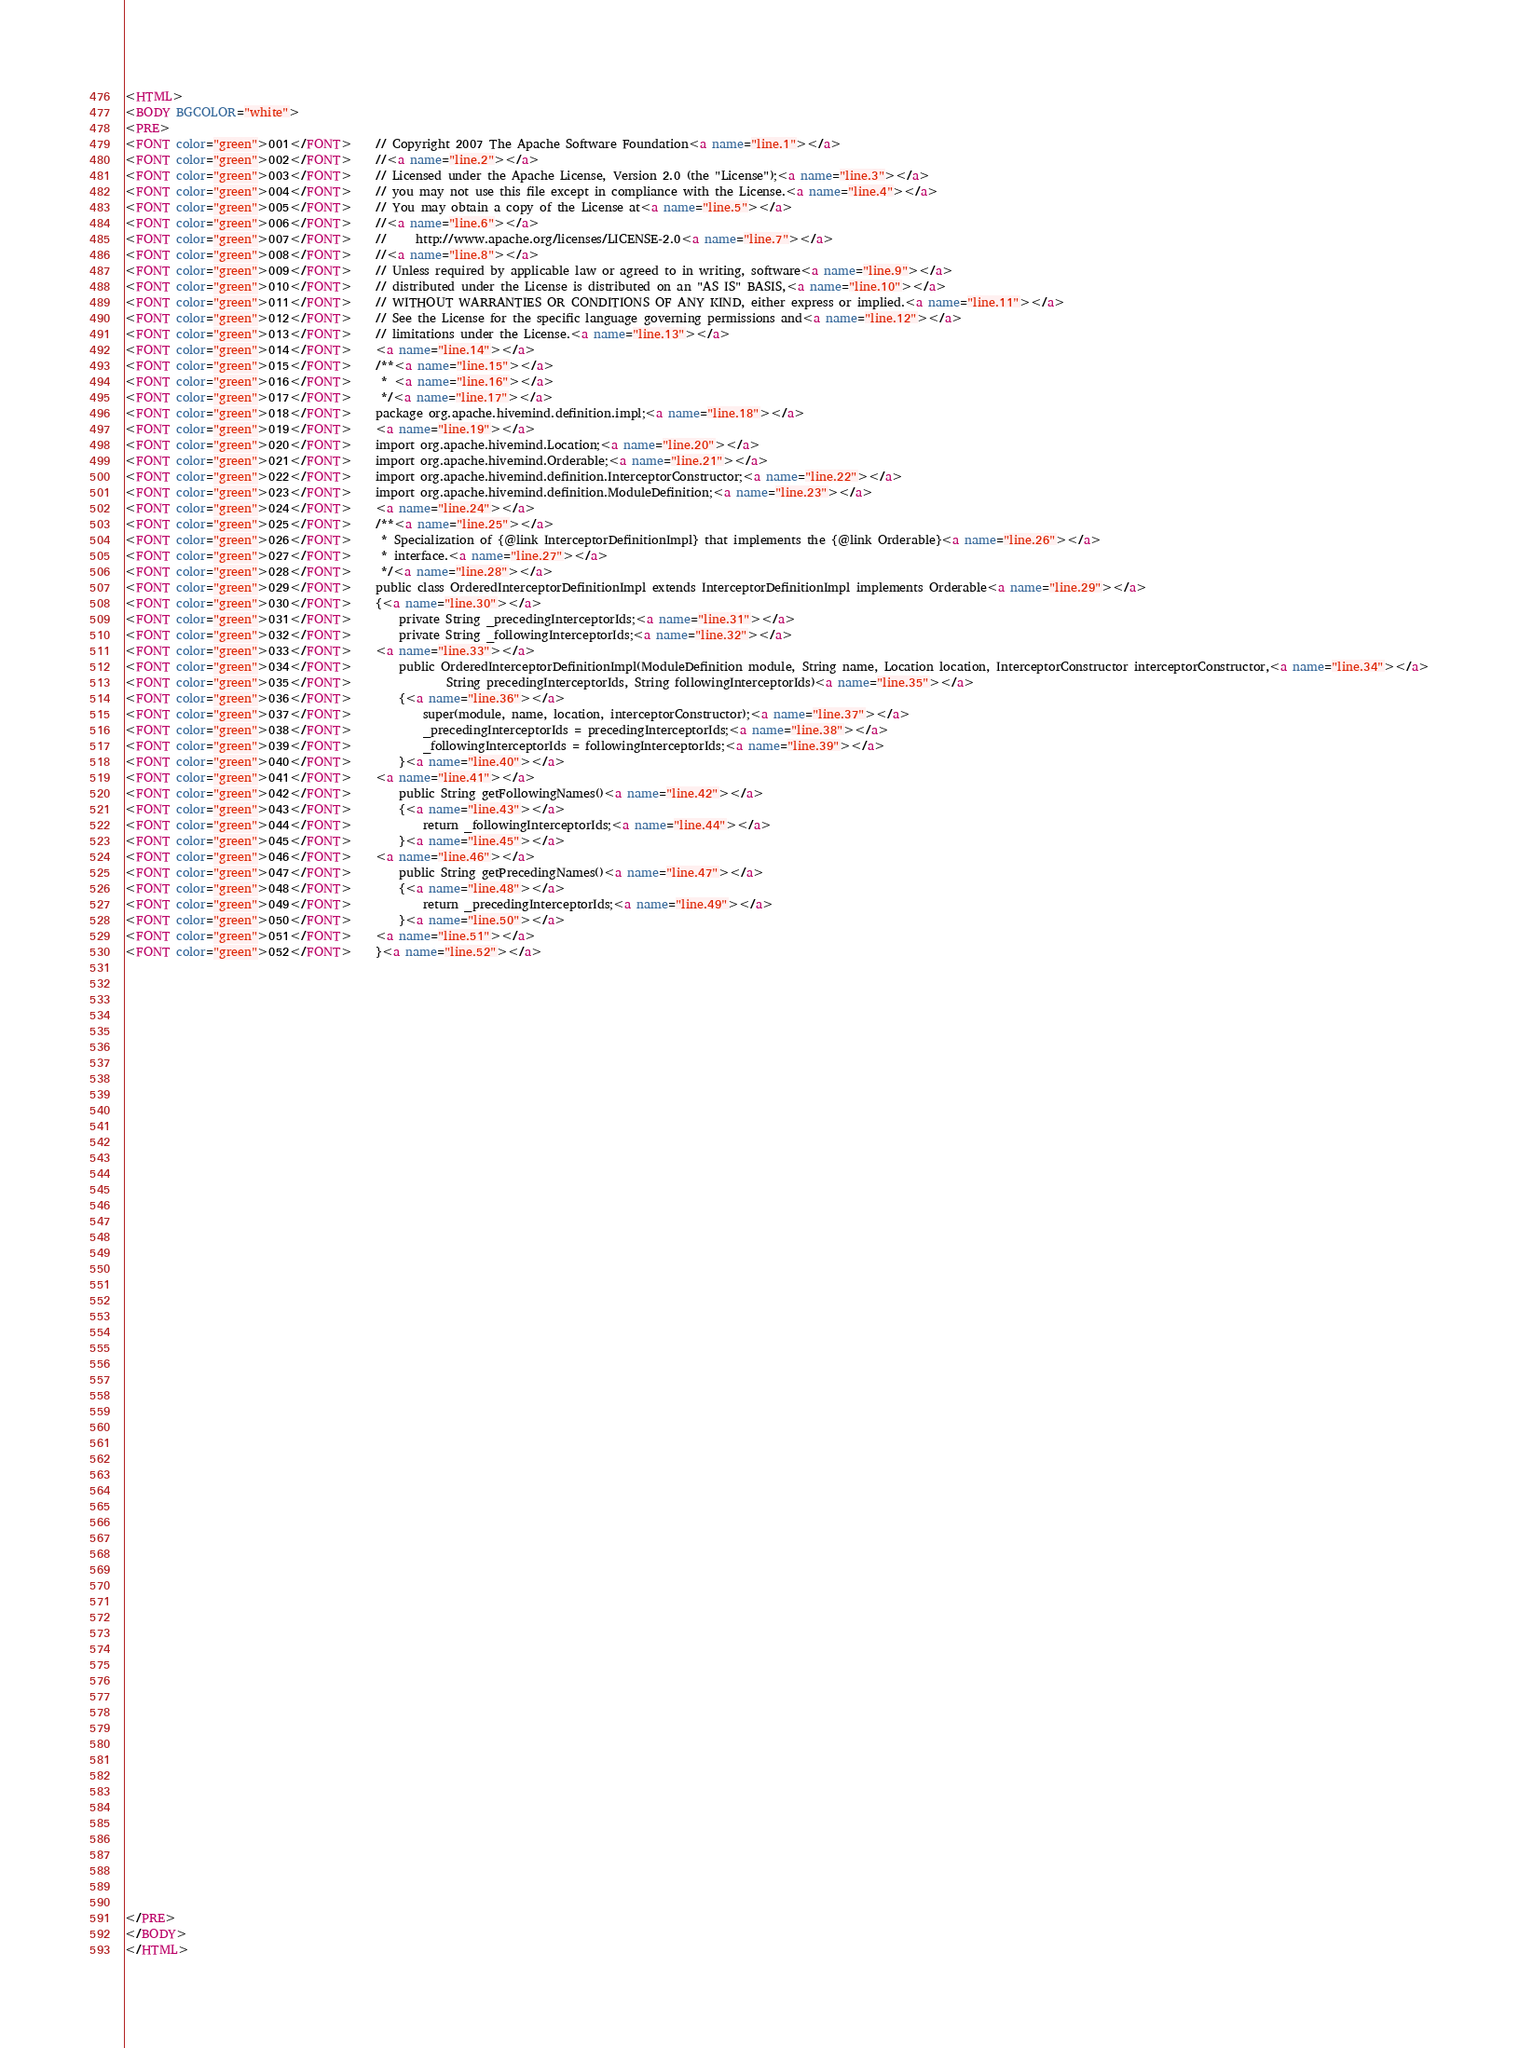<code> <loc_0><loc_0><loc_500><loc_500><_HTML_><HTML>
<BODY BGCOLOR="white">
<PRE>
<FONT color="green">001</FONT>    // Copyright 2007 The Apache Software Foundation<a name="line.1"></a>
<FONT color="green">002</FONT>    //<a name="line.2"></a>
<FONT color="green">003</FONT>    // Licensed under the Apache License, Version 2.0 (the "License");<a name="line.3"></a>
<FONT color="green">004</FONT>    // you may not use this file except in compliance with the License.<a name="line.4"></a>
<FONT color="green">005</FONT>    // You may obtain a copy of the License at<a name="line.5"></a>
<FONT color="green">006</FONT>    //<a name="line.6"></a>
<FONT color="green">007</FONT>    //     http://www.apache.org/licenses/LICENSE-2.0<a name="line.7"></a>
<FONT color="green">008</FONT>    //<a name="line.8"></a>
<FONT color="green">009</FONT>    // Unless required by applicable law or agreed to in writing, software<a name="line.9"></a>
<FONT color="green">010</FONT>    // distributed under the License is distributed on an "AS IS" BASIS,<a name="line.10"></a>
<FONT color="green">011</FONT>    // WITHOUT WARRANTIES OR CONDITIONS OF ANY KIND, either express or implied.<a name="line.11"></a>
<FONT color="green">012</FONT>    // See the License for the specific language governing permissions and<a name="line.12"></a>
<FONT color="green">013</FONT>    // limitations under the License.<a name="line.13"></a>
<FONT color="green">014</FONT>    <a name="line.14"></a>
<FONT color="green">015</FONT>    /**<a name="line.15"></a>
<FONT color="green">016</FONT>     * <a name="line.16"></a>
<FONT color="green">017</FONT>     */<a name="line.17"></a>
<FONT color="green">018</FONT>    package org.apache.hivemind.definition.impl;<a name="line.18"></a>
<FONT color="green">019</FONT>    <a name="line.19"></a>
<FONT color="green">020</FONT>    import org.apache.hivemind.Location;<a name="line.20"></a>
<FONT color="green">021</FONT>    import org.apache.hivemind.Orderable;<a name="line.21"></a>
<FONT color="green">022</FONT>    import org.apache.hivemind.definition.InterceptorConstructor;<a name="line.22"></a>
<FONT color="green">023</FONT>    import org.apache.hivemind.definition.ModuleDefinition;<a name="line.23"></a>
<FONT color="green">024</FONT>    <a name="line.24"></a>
<FONT color="green">025</FONT>    /**<a name="line.25"></a>
<FONT color="green">026</FONT>     * Specialization of {@link InterceptorDefinitionImpl} that implements the {@link Orderable}<a name="line.26"></a>
<FONT color="green">027</FONT>     * interface.<a name="line.27"></a>
<FONT color="green">028</FONT>     */<a name="line.28"></a>
<FONT color="green">029</FONT>    public class OrderedInterceptorDefinitionImpl extends InterceptorDefinitionImpl implements Orderable<a name="line.29"></a>
<FONT color="green">030</FONT>    {<a name="line.30"></a>
<FONT color="green">031</FONT>        private String _precedingInterceptorIds;<a name="line.31"></a>
<FONT color="green">032</FONT>        private String _followingInterceptorIds;<a name="line.32"></a>
<FONT color="green">033</FONT>    <a name="line.33"></a>
<FONT color="green">034</FONT>        public OrderedInterceptorDefinitionImpl(ModuleDefinition module, String name, Location location, InterceptorConstructor interceptorConstructor,<a name="line.34"></a>
<FONT color="green">035</FONT>                String precedingInterceptorIds, String followingInterceptorIds)<a name="line.35"></a>
<FONT color="green">036</FONT>        {<a name="line.36"></a>
<FONT color="green">037</FONT>            super(module, name, location, interceptorConstructor);<a name="line.37"></a>
<FONT color="green">038</FONT>            _precedingInterceptorIds = precedingInterceptorIds;<a name="line.38"></a>
<FONT color="green">039</FONT>            _followingInterceptorIds = followingInterceptorIds;<a name="line.39"></a>
<FONT color="green">040</FONT>        }<a name="line.40"></a>
<FONT color="green">041</FONT>    <a name="line.41"></a>
<FONT color="green">042</FONT>        public String getFollowingNames()<a name="line.42"></a>
<FONT color="green">043</FONT>        {<a name="line.43"></a>
<FONT color="green">044</FONT>            return _followingInterceptorIds;<a name="line.44"></a>
<FONT color="green">045</FONT>        }<a name="line.45"></a>
<FONT color="green">046</FONT>    <a name="line.46"></a>
<FONT color="green">047</FONT>        public String getPrecedingNames()<a name="line.47"></a>
<FONT color="green">048</FONT>        {<a name="line.48"></a>
<FONT color="green">049</FONT>            return _precedingInterceptorIds;<a name="line.49"></a>
<FONT color="green">050</FONT>        }<a name="line.50"></a>
<FONT color="green">051</FONT>    <a name="line.51"></a>
<FONT color="green">052</FONT>    }<a name="line.52"></a>




























































</PRE>
</BODY>
</HTML>
</code> 